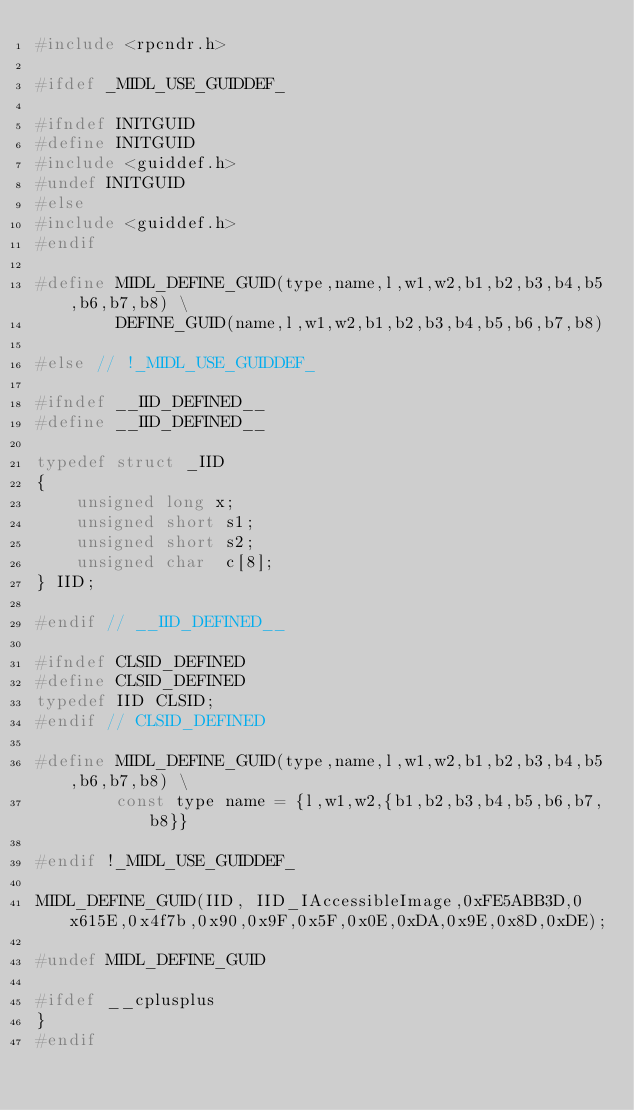Convert code to text. <code><loc_0><loc_0><loc_500><loc_500><_C_>#include <rpcndr.h>

#ifdef _MIDL_USE_GUIDDEF_

#ifndef INITGUID
#define INITGUID
#include <guiddef.h>
#undef INITGUID
#else
#include <guiddef.h>
#endif

#define MIDL_DEFINE_GUID(type,name,l,w1,w2,b1,b2,b3,b4,b5,b6,b7,b8) \
        DEFINE_GUID(name,l,w1,w2,b1,b2,b3,b4,b5,b6,b7,b8)

#else // !_MIDL_USE_GUIDDEF_

#ifndef __IID_DEFINED__
#define __IID_DEFINED__

typedef struct _IID
{
    unsigned long x;
    unsigned short s1;
    unsigned short s2;
    unsigned char  c[8];
} IID;

#endif // __IID_DEFINED__

#ifndef CLSID_DEFINED
#define CLSID_DEFINED
typedef IID CLSID;
#endif // CLSID_DEFINED

#define MIDL_DEFINE_GUID(type,name,l,w1,w2,b1,b2,b3,b4,b5,b6,b7,b8) \
        const type name = {l,w1,w2,{b1,b2,b3,b4,b5,b6,b7,b8}}

#endif !_MIDL_USE_GUIDDEF_

MIDL_DEFINE_GUID(IID, IID_IAccessibleImage,0xFE5ABB3D,0x615E,0x4f7b,0x90,0x9F,0x5F,0x0E,0xDA,0x9E,0x8D,0xDE);

#undef MIDL_DEFINE_GUID

#ifdef __cplusplus
}
#endif



</code> 